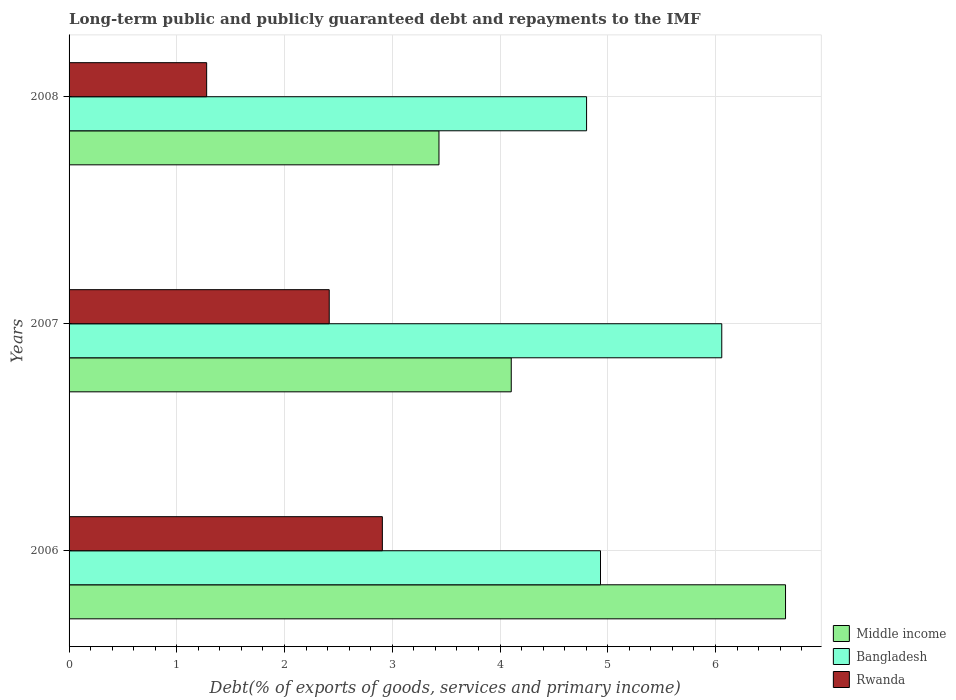Are the number of bars per tick equal to the number of legend labels?
Make the answer very short. Yes. How many bars are there on the 2nd tick from the bottom?
Make the answer very short. 3. What is the label of the 1st group of bars from the top?
Offer a terse response. 2008. In how many cases, is the number of bars for a given year not equal to the number of legend labels?
Keep it short and to the point. 0. What is the debt and repayments in Middle income in 2007?
Your answer should be compact. 4.1. Across all years, what is the maximum debt and repayments in Middle income?
Offer a terse response. 6.65. Across all years, what is the minimum debt and repayments in Rwanda?
Make the answer very short. 1.28. In which year was the debt and repayments in Bangladesh minimum?
Give a very brief answer. 2008. What is the total debt and repayments in Rwanda in the graph?
Offer a terse response. 6.6. What is the difference between the debt and repayments in Rwanda in 2006 and that in 2007?
Your answer should be compact. 0.49. What is the difference between the debt and repayments in Bangladesh in 2008 and the debt and repayments in Middle income in 2007?
Your answer should be compact. 0.7. What is the average debt and repayments in Middle income per year?
Offer a terse response. 4.73. In the year 2008, what is the difference between the debt and repayments in Rwanda and debt and repayments in Bangladesh?
Make the answer very short. -3.53. In how many years, is the debt and repayments in Bangladesh greater than 6.2 %?
Offer a very short reply. 0. What is the ratio of the debt and repayments in Rwanda in 2006 to that in 2007?
Your answer should be very brief. 1.2. What is the difference between the highest and the second highest debt and repayments in Bangladesh?
Provide a short and direct response. 1.13. What is the difference between the highest and the lowest debt and repayments in Middle income?
Your answer should be compact. 3.22. In how many years, is the debt and repayments in Middle income greater than the average debt and repayments in Middle income taken over all years?
Offer a terse response. 1. What does the 2nd bar from the top in 2008 represents?
Your answer should be compact. Bangladesh. What does the 3rd bar from the bottom in 2006 represents?
Offer a very short reply. Rwanda. Are all the bars in the graph horizontal?
Provide a succinct answer. Yes. Are the values on the major ticks of X-axis written in scientific E-notation?
Your response must be concise. No. Does the graph contain any zero values?
Ensure brevity in your answer.  No. Does the graph contain grids?
Your answer should be very brief. Yes. Where does the legend appear in the graph?
Your answer should be very brief. Bottom right. How many legend labels are there?
Keep it short and to the point. 3. What is the title of the graph?
Your answer should be compact. Long-term public and publicly guaranteed debt and repayments to the IMF. Does "New Zealand" appear as one of the legend labels in the graph?
Provide a succinct answer. No. What is the label or title of the X-axis?
Give a very brief answer. Debt(% of exports of goods, services and primary income). What is the label or title of the Y-axis?
Provide a short and direct response. Years. What is the Debt(% of exports of goods, services and primary income) of Middle income in 2006?
Provide a succinct answer. 6.65. What is the Debt(% of exports of goods, services and primary income) of Bangladesh in 2006?
Provide a succinct answer. 4.93. What is the Debt(% of exports of goods, services and primary income) of Rwanda in 2006?
Provide a succinct answer. 2.91. What is the Debt(% of exports of goods, services and primary income) in Middle income in 2007?
Offer a very short reply. 4.1. What is the Debt(% of exports of goods, services and primary income) in Bangladesh in 2007?
Your answer should be very brief. 6.06. What is the Debt(% of exports of goods, services and primary income) in Rwanda in 2007?
Your response must be concise. 2.41. What is the Debt(% of exports of goods, services and primary income) in Middle income in 2008?
Give a very brief answer. 3.43. What is the Debt(% of exports of goods, services and primary income) in Bangladesh in 2008?
Keep it short and to the point. 4.8. What is the Debt(% of exports of goods, services and primary income) of Rwanda in 2008?
Offer a very short reply. 1.28. Across all years, what is the maximum Debt(% of exports of goods, services and primary income) of Middle income?
Your answer should be very brief. 6.65. Across all years, what is the maximum Debt(% of exports of goods, services and primary income) of Bangladesh?
Offer a terse response. 6.06. Across all years, what is the maximum Debt(% of exports of goods, services and primary income) in Rwanda?
Your answer should be very brief. 2.91. Across all years, what is the minimum Debt(% of exports of goods, services and primary income) of Middle income?
Ensure brevity in your answer.  3.43. Across all years, what is the minimum Debt(% of exports of goods, services and primary income) in Bangladesh?
Ensure brevity in your answer.  4.8. Across all years, what is the minimum Debt(% of exports of goods, services and primary income) in Rwanda?
Your answer should be very brief. 1.28. What is the total Debt(% of exports of goods, services and primary income) of Middle income in the graph?
Offer a terse response. 14.19. What is the total Debt(% of exports of goods, services and primary income) in Bangladesh in the graph?
Offer a very short reply. 15.79. What is the total Debt(% of exports of goods, services and primary income) in Rwanda in the graph?
Your response must be concise. 6.6. What is the difference between the Debt(% of exports of goods, services and primary income) in Middle income in 2006 and that in 2007?
Provide a short and direct response. 2.55. What is the difference between the Debt(% of exports of goods, services and primary income) in Bangladesh in 2006 and that in 2007?
Give a very brief answer. -1.13. What is the difference between the Debt(% of exports of goods, services and primary income) in Rwanda in 2006 and that in 2007?
Offer a very short reply. 0.49. What is the difference between the Debt(% of exports of goods, services and primary income) of Middle income in 2006 and that in 2008?
Provide a succinct answer. 3.22. What is the difference between the Debt(% of exports of goods, services and primary income) of Bangladesh in 2006 and that in 2008?
Your answer should be very brief. 0.13. What is the difference between the Debt(% of exports of goods, services and primary income) of Rwanda in 2006 and that in 2008?
Offer a terse response. 1.63. What is the difference between the Debt(% of exports of goods, services and primary income) of Middle income in 2007 and that in 2008?
Provide a succinct answer. 0.67. What is the difference between the Debt(% of exports of goods, services and primary income) in Bangladesh in 2007 and that in 2008?
Your response must be concise. 1.25. What is the difference between the Debt(% of exports of goods, services and primary income) in Rwanda in 2007 and that in 2008?
Your answer should be compact. 1.14. What is the difference between the Debt(% of exports of goods, services and primary income) in Middle income in 2006 and the Debt(% of exports of goods, services and primary income) in Bangladesh in 2007?
Keep it short and to the point. 0.59. What is the difference between the Debt(% of exports of goods, services and primary income) of Middle income in 2006 and the Debt(% of exports of goods, services and primary income) of Rwanda in 2007?
Your answer should be very brief. 4.24. What is the difference between the Debt(% of exports of goods, services and primary income) in Bangladesh in 2006 and the Debt(% of exports of goods, services and primary income) in Rwanda in 2007?
Offer a very short reply. 2.52. What is the difference between the Debt(% of exports of goods, services and primary income) in Middle income in 2006 and the Debt(% of exports of goods, services and primary income) in Bangladesh in 2008?
Offer a terse response. 1.85. What is the difference between the Debt(% of exports of goods, services and primary income) of Middle income in 2006 and the Debt(% of exports of goods, services and primary income) of Rwanda in 2008?
Offer a terse response. 5.37. What is the difference between the Debt(% of exports of goods, services and primary income) in Bangladesh in 2006 and the Debt(% of exports of goods, services and primary income) in Rwanda in 2008?
Provide a succinct answer. 3.66. What is the difference between the Debt(% of exports of goods, services and primary income) in Middle income in 2007 and the Debt(% of exports of goods, services and primary income) in Bangladesh in 2008?
Keep it short and to the point. -0.7. What is the difference between the Debt(% of exports of goods, services and primary income) in Middle income in 2007 and the Debt(% of exports of goods, services and primary income) in Rwanda in 2008?
Provide a succinct answer. 2.83. What is the difference between the Debt(% of exports of goods, services and primary income) in Bangladesh in 2007 and the Debt(% of exports of goods, services and primary income) in Rwanda in 2008?
Make the answer very short. 4.78. What is the average Debt(% of exports of goods, services and primary income) in Middle income per year?
Provide a short and direct response. 4.73. What is the average Debt(% of exports of goods, services and primary income) of Bangladesh per year?
Your response must be concise. 5.26. What is the average Debt(% of exports of goods, services and primary income) of Rwanda per year?
Your answer should be very brief. 2.2. In the year 2006, what is the difference between the Debt(% of exports of goods, services and primary income) in Middle income and Debt(% of exports of goods, services and primary income) in Bangladesh?
Provide a short and direct response. 1.72. In the year 2006, what is the difference between the Debt(% of exports of goods, services and primary income) of Middle income and Debt(% of exports of goods, services and primary income) of Rwanda?
Give a very brief answer. 3.74. In the year 2006, what is the difference between the Debt(% of exports of goods, services and primary income) of Bangladesh and Debt(% of exports of goods, services and primary income) of Rwanda?
Make the answer very short. 2.02. In the year 2007, what is the difference between the Debt(% of exports of goods, services and primary income) of Middle income and Debt(% of exports of goods, services and primary income) of Bangladesh?
Your answer should be very brief. -1.95. In the year 2007, what is the difference between the Debt(% of exports of goods, services and primary income) in Middle income and Debt(% of exports of goods, services and primary income) in Rwanda?
Ensure brevity in your answer.  1.69. In the year 2007, what is the difference between the Debt(% of exports of goods, services and primary income) in Bangladesh and Debt(% of exports of goods, services and primary income) in Rwanda?
Make the answer very short. 3.64. In the year 2008, what is the difference between the Debt(% of exports of goods, services and primary income) in Middle income and Debt(% of exports of goods, services and primary income) in Bangladesh?
Keep it short and to the point. -1.37. In the year 2008, what is the difference between the Debt(% of exports of goods, services and primary income) in Middle income and Debt(% of exports of goods, services and primary income) in Rwanda?
Ensure brevity in your answer.  2.16. In the year 2008, what is the difference between the Debt(% of exports of goods, services and primary income) in Bangladesh and Debt(% of exports of goods, services and primary income) in Rwanda?
Make the answer very short. 3.53. What is the ratio of the Debt(% of exports of goods, services and primary income) in Middle income in 2006 to that in 2007?
Provide a short and direct response. 1.62. What is the ratio of the Debt(% of exports of goods, services and primary income) in Bangladesh in 2006 to that in 2007?
Provide a short and direct response. 0.81. What is the ratio of the Debt(% of exports of goods, services and primary income) in Rwanda in 2006 to that in 2007?
Provide a succinct answer. 1.2. What is the ratio of the Debt(% of exports of goods, services and primary income) in Middle income in 2006 to that in 2008?
Provide a short and direct response. 1.94. What is the ratio of the Debt(% of exports of goods, services and primary income) of Bangladesh in 2006 to that in 2008?
Ensure brevity in your answer.  1.03. What is the ratio of the Debt(% of exports of goods, services and primary income) in Rwanda in 2006 to that in 2008?
Keep it short and to the point. 2.28. What is the ratio of the Debt(% of exports of goods, services and primary income) of Middle income in 2007 to that in 2008?
Provide a succinct answer. 1.2. What is the ratio of the Debt(% of exports of goods, services and primary income) of Bangladesh in 2007 to that in 2008?
Offer a very short reply. 1.26. What is the ratio of the Debt(% of exports of goods, services and primary income) of Rwanda in 2007 to that in 2008?
Keep it short and to the point. 1.89. What is the difference between the highest and the second highest Debt(% of exports of goods, services and primary income) in Middle income?
Your answer should be very brief. 2.55. What is the difference between the highest and the second highest Debt(% of exports of goods, services and primary income) of Bangladesh?
Ensure brevity in your answer.  1.13. What is the difference between the highest and the second highest Debt(% of exports of goods, services and primary income) of Rwanda?
Your response must be concise. 0.49. What is the difference between the highest and the lowest Debt(% of exports of goods, services and primary income) of Middle income?
Offer a terse response. 3.22. What is the difference between the highest and the lowest Debt(% of exports of goods, services and primary income) in Bangladesh?
Offer a terse response. 1.25. What is the difference between the highest and the lowest Debt(% of exports of goods, services and primary income) of Rwanda?
Your response must be concise. 1.63. 